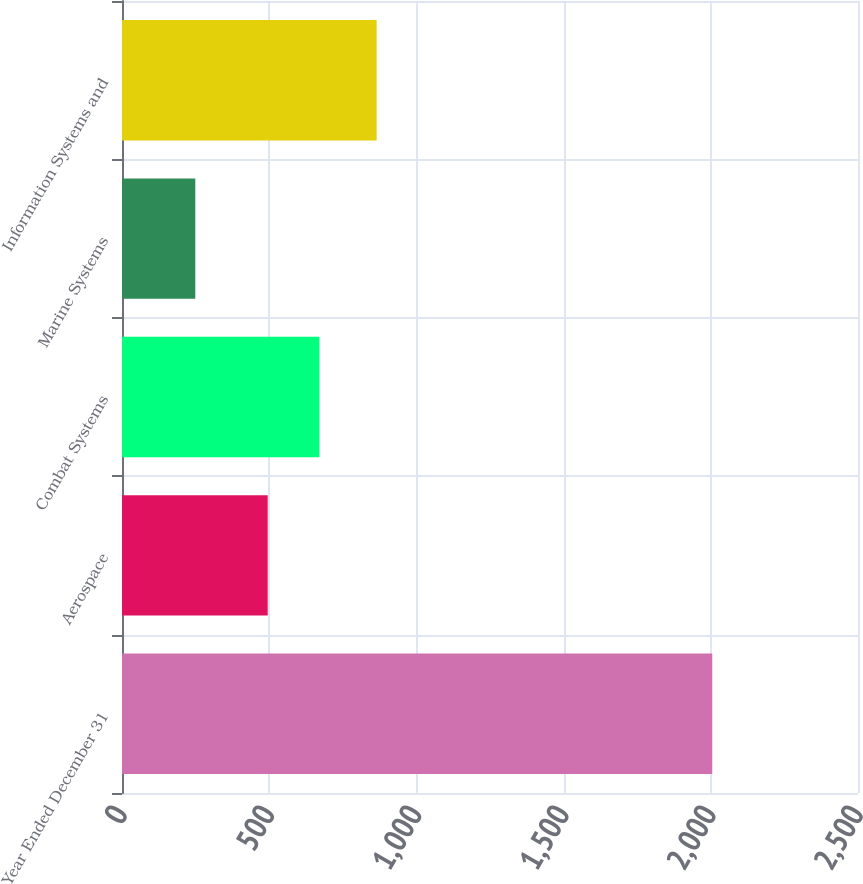<chart> <loc_0><loc_0><loc_500><loc_500><bar_chart><fcel>Year Ended December 31<fcel>Aerospace<fcel>Combat Systems<fcel>Marine Systems<fcel>Information Systems and<nl><fcel>2005<fcel>495<fcel>670.6<fcel>249<fcel>865<nl></chart> 